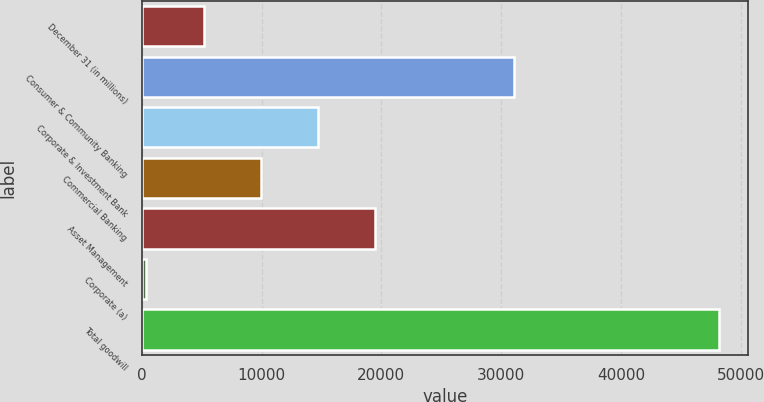Convert chart to OTSL. <chart><loc_0><loc_0><loc_500><loc_500><bar_chart><fcel>December 31 (in millions)<fcel>Consumer & Community Banking<fcel>Corporate & Investment Bank<fcel>Commercial Banking<fcel>Asset Management<fcel>Corporate (a)<fcel>Total goodwill<nl><fcel>5156.8<fcel>31048<fcel>14716.4<fcel>9936.6<fcel>19496.2<fcel>377<fcel>48175<nl></chart> 